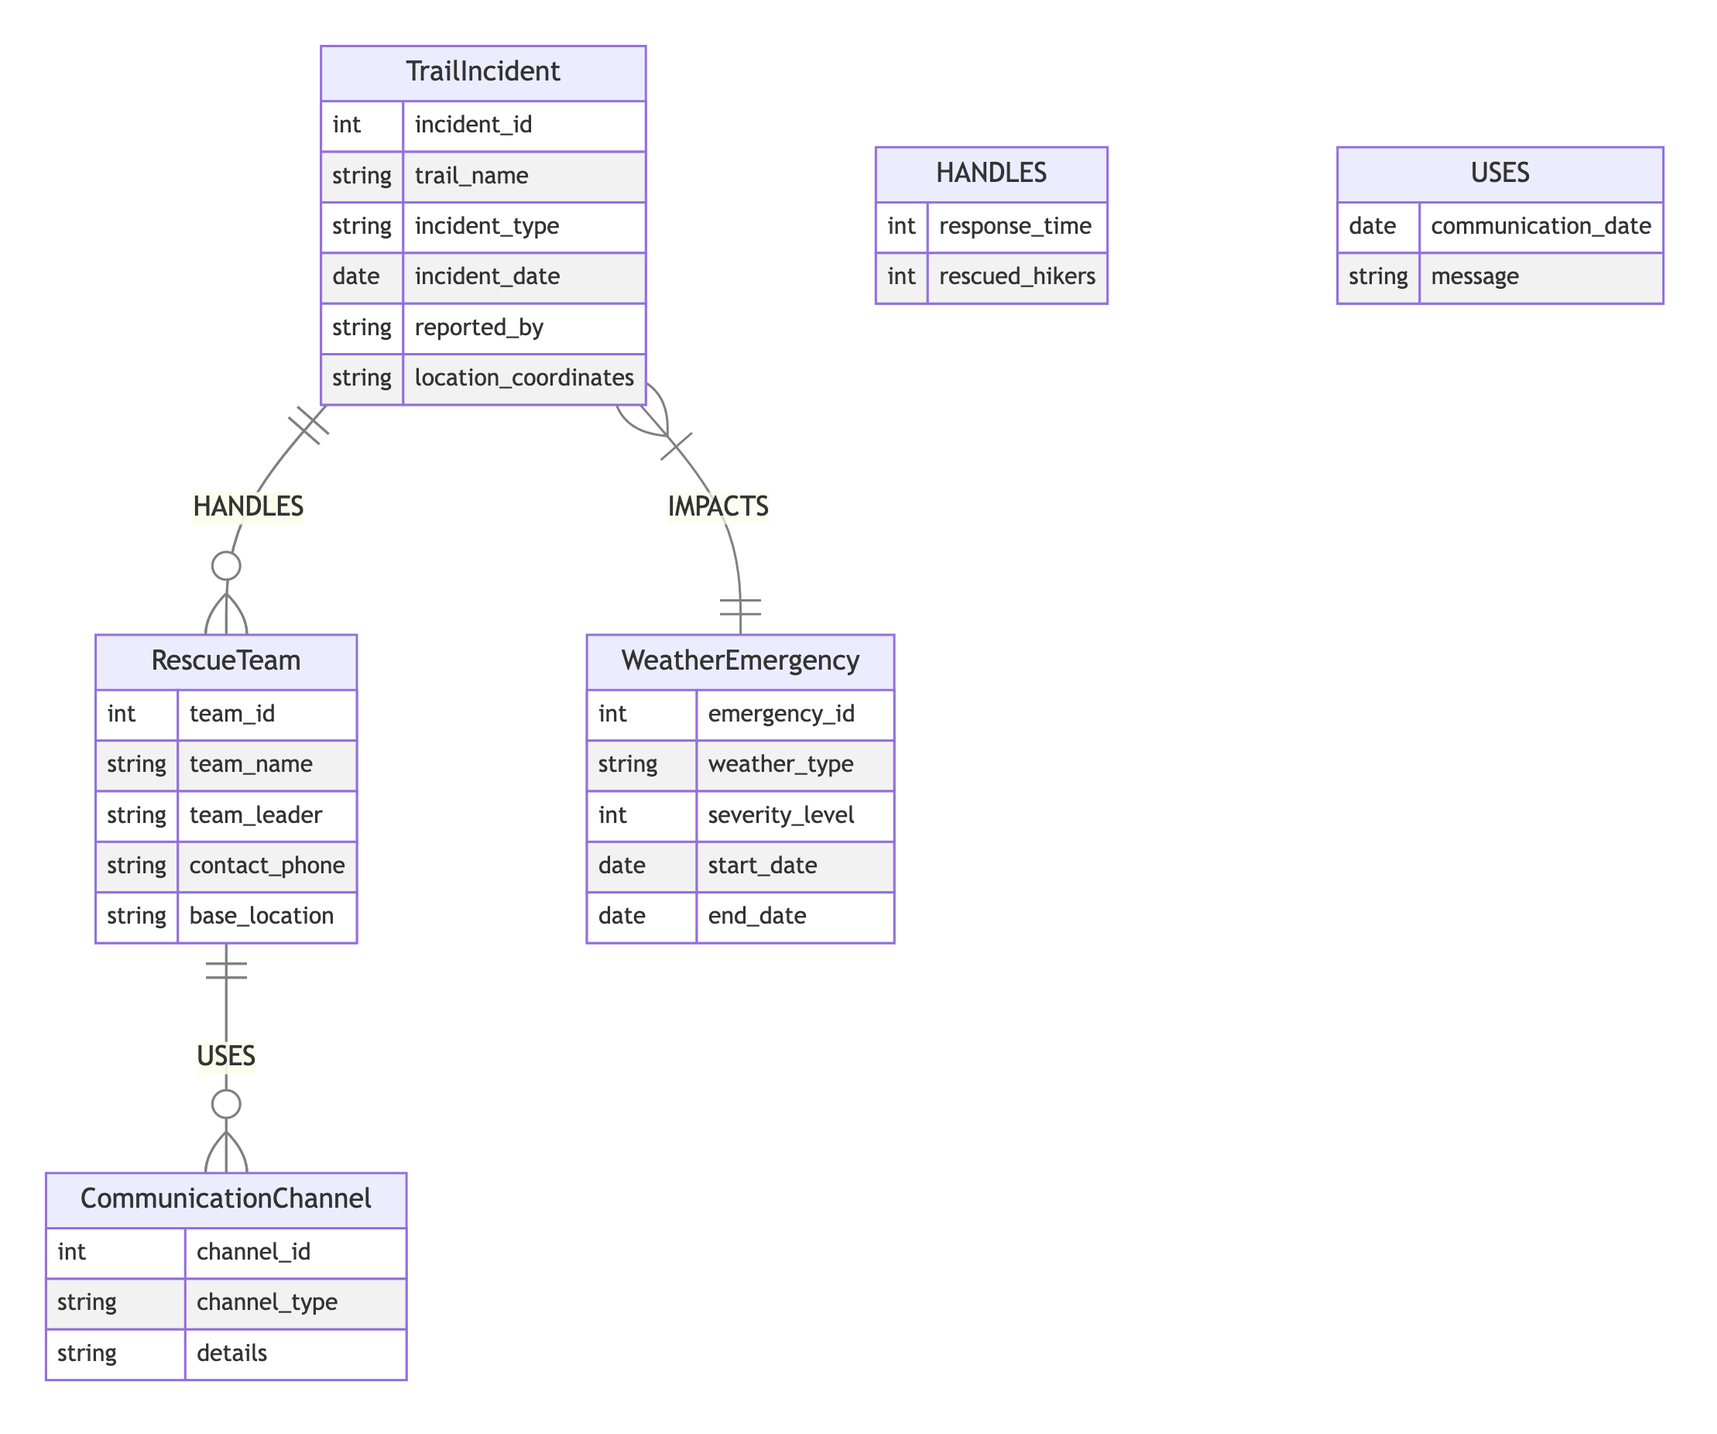What are the entities represented in the diagram? The diagram includes four entities: TrailIncident, RescueTeam, WeatherEmergency, and CommunicationChannel. A careful examination of the diagram identifies each entity by its title listed in the respective sections.
Answer: TrailIncident, RescueTeam, WeatherEmergency, CommunicationChannel What is the primary relationship between TrailIncident and RescueTeam? The relationship between TrailIncident and RescueTeam is defined as HANDLES. The diagram indicates this relationship with a line connecting the two entities and labels it accordingly.
Answer: HANDLES How many attributes does the RescueTeam entity have? The RescueTeam entity has five attributes: team_id, team_name, team_leader, contact_phone, and base_location. This can be counted by inspecting the attribute list under the RescueTeam section of the diagram.
Answer: Five What is the nature of the relationship between WeatherEmergency and TrailIncident? The relationship between WeatherEmergency and TrailIncident is described as IMPACTS. The diagram explicitly outlines this relationship connecting the two entities, which allows for understanding how weather emergencies influence trail incidents.
Answer: IMPACTS What attribute is shared between RescueTeam and CommunicationChannel in their relationship? The shared attributes in the relationship between RescueTeam and CommunicationChannel include communication_date and message. These attributes are listed in the connected relationship section beneath the line linking the two entities in the diagram.
Answer: communication_date, message Which entity has the attribute 'severity_level'? The attribute 'severity_level' is associated with the WeatherEmergency entity. By analyzing the attributes listed under each entity, we can determine which entity holds specific attributes.
Answer: WeatherEmergency How does a RescueTeam respond to a TrailIncident? A RescueTeam responds to a TrailIncident through the HANDLES relationship, which includes attributes such as response_time and rescued_hikers. This means a RescueTeam's performance can be quantified by these specific metrics within the defined relationship.
Answer: response_time, rescued_hikers What type of emergencies does the WeatherEmergency entity cover? The WeatherEmergency entity covers emergencies of various weather types, such as extreme storms, floods, or heatwaves. The attribute weather_type indicates the nature of the emergency covered, and this can be inferred from the entity's purpose as stated in the diagram.
Answer: weather_type How many different types of communication channels are there in the diagram? The diagram includes one CommunicationChannel entity, which can encompass multiple types of channels, but only one is represented in the diagram as a distinct entity. The observation counts the unique CommunicationChannel entity within the diagram.
Answer: One 